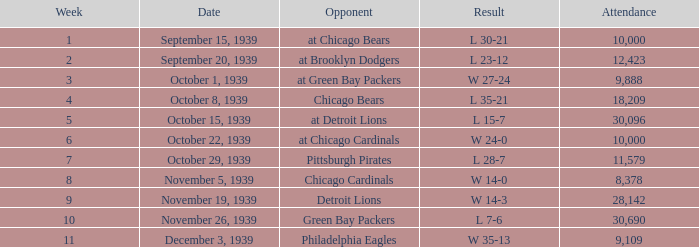In which attendance do the green bay packers face an opponent during a week beyond the 10th? None. 